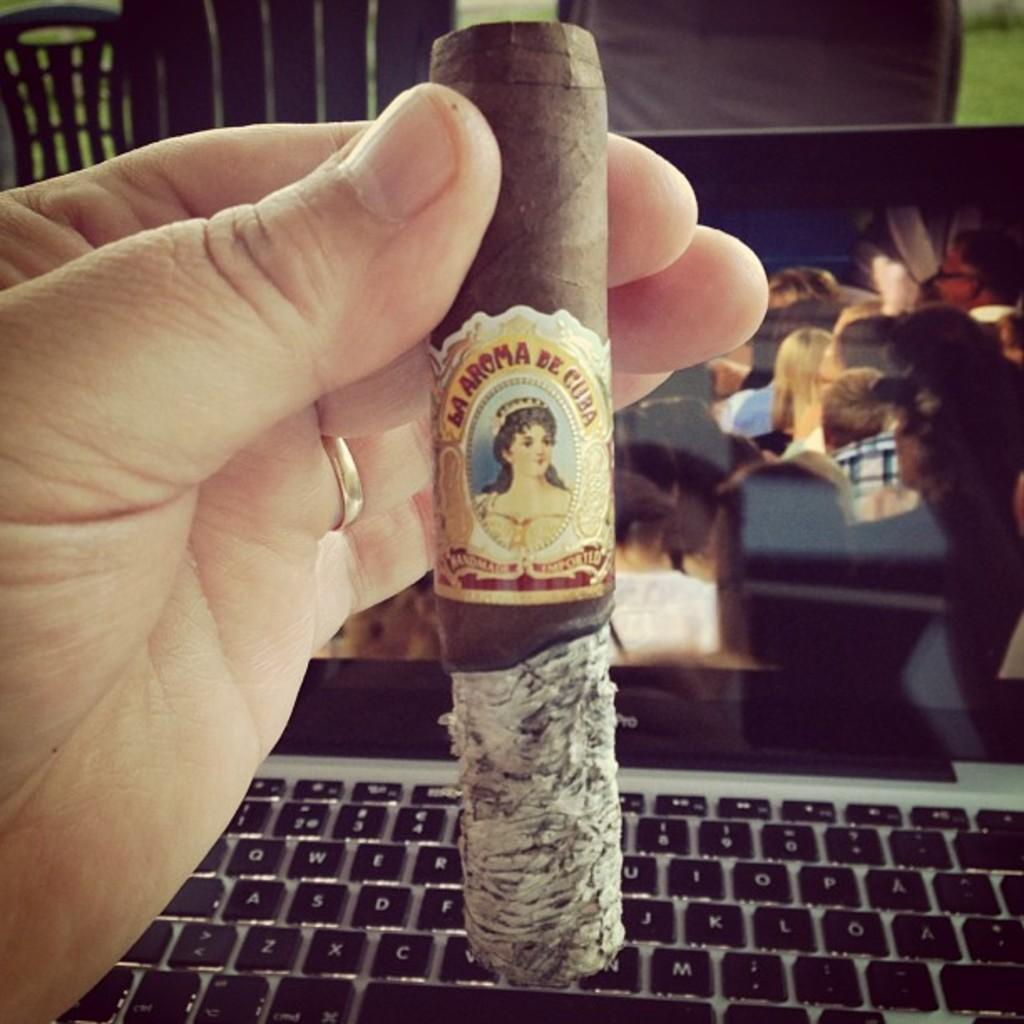<image>
Describe the image concisely. A hand holding a large cigar with the word Cuba on it 